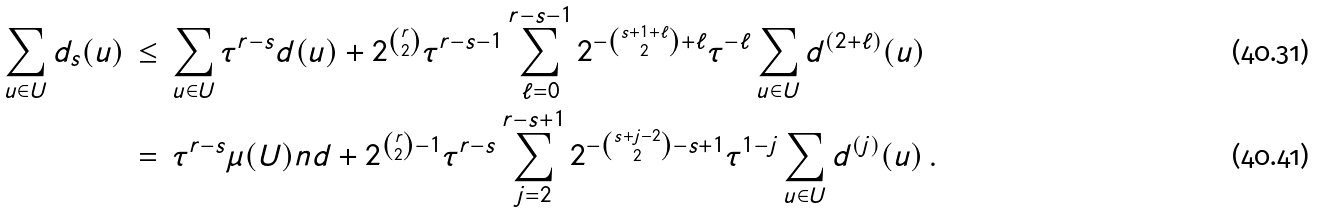<formula> <loc_0><loc_0><loc_500><loc_500>\sum _ { u \in U } d _ { s } ( u ) \, & \leq \, \sum _ { u \in U } \tau ^ { r - s } d ( u ) + 2 ^ { r \choose 2 } \tau ^ { r - s - 1 } \sum _ { \ell = 0 } ^ { r - s - 1 } 2 ^ { - { s + 1 + \ell \choose 2 } + \ell } \tau ^ { - \ell } \sum _ { u \in U } d ^ { ( 2 + \ell ) } ( u ) \\ & = \, \tau ^ { r - s } \mu ( U ) n d + 2 ^ { { r \choose 2 } - 1 } \tau ^ { r - s } \sum _ { j = 2 } ^ { r - s + 1 } 2 ^ { - { s + j - 2 \choose 2 } - s + 1 } \tau ^ { 1 - j } \sum _ { u \in U } d ^ { ( j ) } ( u ) \, .</formula> 